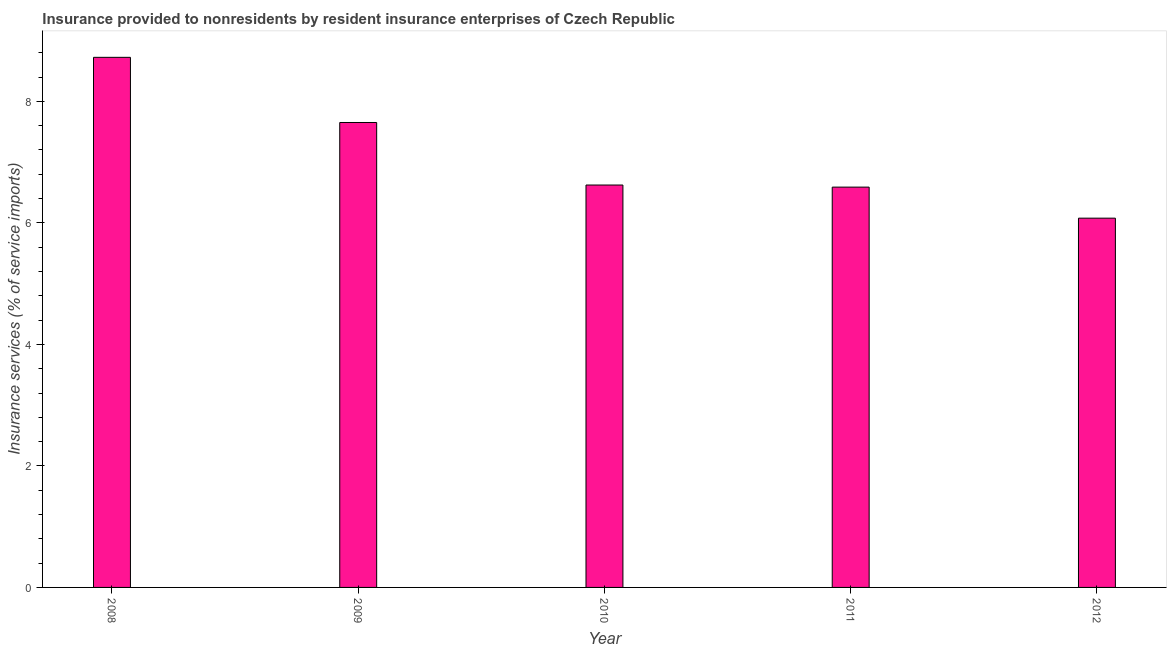Does the graph contain any zero values?
Provide a succinct answer. No. What is the title of the graph?
Your answer should be compact. Insurance provided to nonresidents by resident insurance enterprises of Czech Republic. What is the label or title of the Y-axis?
Make the answer very short. Insurance services (% of service imports). What is the insurance and financial services in 2012?
Your answer should be compact. 6.08. Across all years, what is the maximum insurance and financial services?
Make the answer very short. 8.72. Across all years, what is the minimum insurance and financial services?
Your response must be concise. 6.08. In which year was the insurance and financial services minimum?
Give a very brief answer. 2012. What is the sum of the insurance and financial services?
Offer a very short reply. 35.67. What is the difference between the insurance and financial services in 2008 and 2011?
Ensure brevity in your answer.  2.14. What is the average insurance and financial services per year?
Offer a terse response. 7.13. What is the median insurance and financial services?
Make the answer very short. 6.62. Do a majority of the years between 2008 and 2011 (inclusive) have insurance and financial services greater than 4.4 %?
Your answer should be very brief. Yes. What is the ratio of the insurance and financial services in 2008 to that in 2011?
Offer a terse response. 1.32. Is the insurance and financial services in 2008 less than that in 2009?
Offer a terse response. No. What is the difference between the highest and the second highest insurance and financial services?
Offer a very short reply. 1.07. Is the sum of the insurance and financial services in 2008 and 2010 greater than the maximum insurance and financial services across all years?
Make the answer very short. Yes. What is the difference between the highest and the lowest insurance and financial services?
Keep it short and to the point. 2.65. In how many years, is the insurance and financial services greater than the average insurance and financial services taken over all years?
Your answer should be compact. 2. How many bars are there?
Give a very brief answer. 5. Are all the bars in the graph horizontal?
Your answer should be compact. No. What is the difference between two consecutive major ticks on the Y-axis?
Offer a very short reply. 2. Are the values on the major ticks of Y-axis written in scientific E-notation?
Ensure brevity in your answer.  No. What is the Insurance services (% of service imports) of 2008?
Ensure brevity in your answer.  8.72. What is the Insurance services (% of service imports) of 2009?
Your answer should be compact. 7.65. What is the Insurance services (% of service imports) in 2010?
Give a very brief answer. 6.62. What is the Insurance services (% of service imports) of 2011?
Provide a short and direct response. 6.59. What is the Insurance services (% of service imports) of 2012?
Give a very brief answer. 6.08. What is the difference between the Insurance services (% of service imports) in 2008 and 2009?
Provide a succinct answer. 1.07. What is the difference between the Insurance services (% of service imports) in 2008 and 2010?
Provide a short and direct response. 2.1. What is the difference between the Insurance services (% of service imports) in 2008 and 2011?
Give a very brief answer. 2.14. What is the difference between the Insurance services (% of service imports) in 2008 and 2012?
Your answer should be compact. 2.65. What is the difference between the Insurance services (% of service imports) in 2009 and 2010?
Provide a succinct answer. 1.03. What is the difference between the Insurance services (% of service imports) in 2009 and 2011?
Your answer should be compact. 1.06. What is the difference between the Insurance services (% of service imports) in 2009 and 2012?
Keep it short and to the point. 1.57. What is the difference between the Insurance services (% of service imports) in 2010 and 2011?
Offer a very short reply. 0.03. What is the difference between the Insurance services (% of service imports) in 2010 and 2012?
Provide a succinct answer. 0.55. What is the difference between the Insurance services (% of service imports) in 2011 and 2012?
Your response must be concise. 0.51. What is the ratio of the Insurance services (% of service imports) in 2008 to that in 2009?
Provide a short and direct response. 1.14. What is the ratio of the Insurance services (% of service imports) in 2008 to that in 2010?
Offer a very short reply. 1.32. What is the ratio of the Insurance services (% of service imports) in 2008 to that in 2011?
Offer a terse response. 1.32. What is the ratio of the Insurance services (% of service imports) in 2008 to that in 2012?
Give a very brief answer. 1.44. What is the ratio of the Insurance services (% of service imports) in 2009 to that in 2010?
Offer a very short reply. 1.16. What is the ratio of the Insurance services (% of service imports) in 2009 to that in 2011?
Your answer should be very brief. 1.16. What is the ratio of the Insurance services (% of service imports) in 2009 to that in 2012?
Offer a terse response. 1.26. What is the ratio of the Insurance services (% of service imports) in 2010 to that in 2011?
Give a very brief answer. 1. What is the ratio of the Insurance services (% of service imports) in 2010 to that in 2012?
Make the answer very short. 1.09. What is the ratio of the Insurance services (% of service imports) in 2011 to that in 2012?
Offer a very short reply. 1.08. 